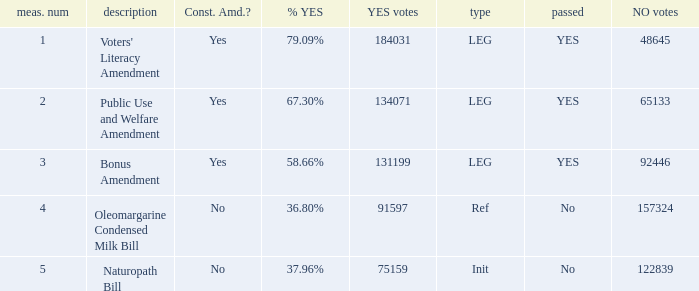What is the measure number for the init type?  5.0. 